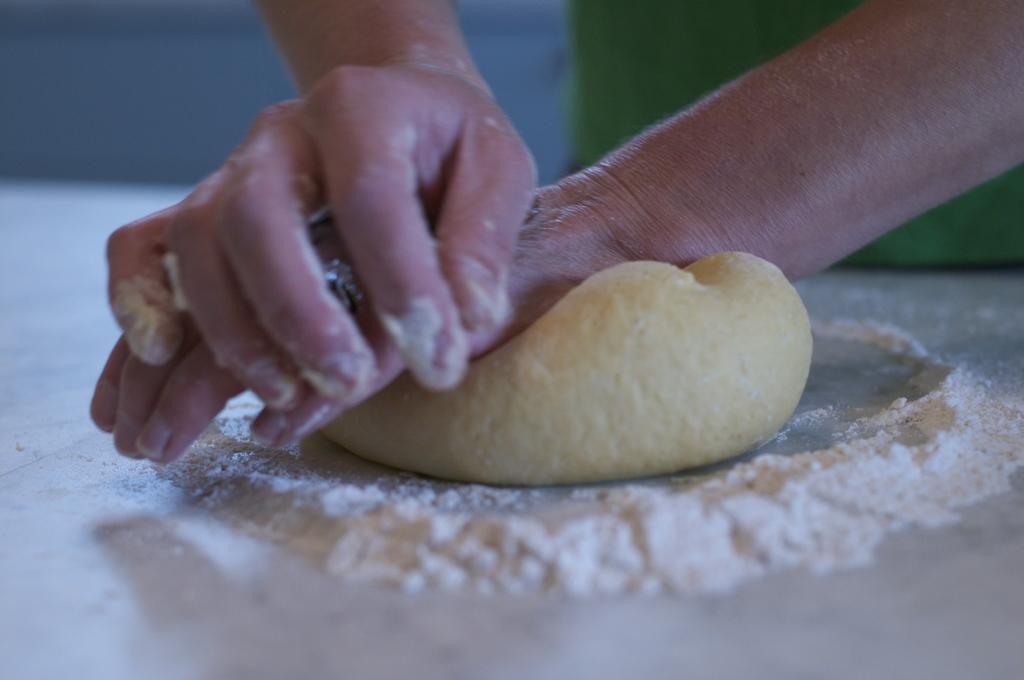Can you describe this image briefly? In the image we can see there is a person standing and he is making dough and there is a flour on the table. 